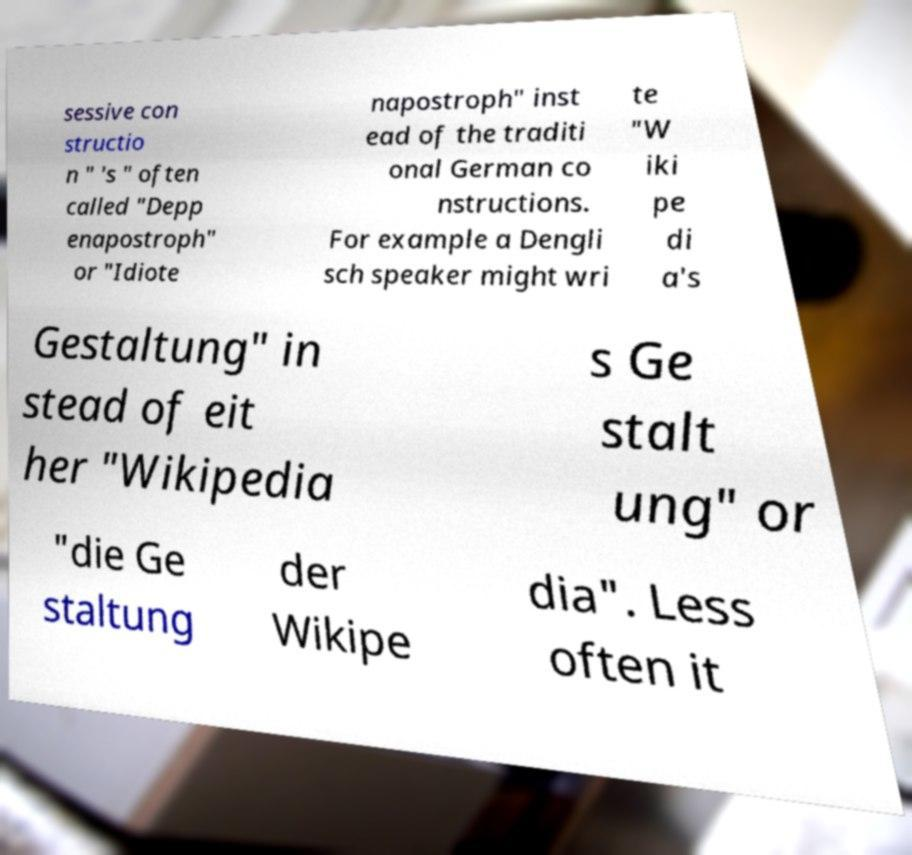Can you accurately transcribe the text from the provided image for me? sessive con structio n " 's " often called "Depp enapostroph" or "Idiote napostroph" inst ead of the traditi onal German co nstructions. For example a Dengli sch speaker might wri te "W iki pe di a's Gestaltung" in stead of eit her "Wikipedia s Ge stalt ung" or "die Ge staltung der Wikipe dia". Less often it 